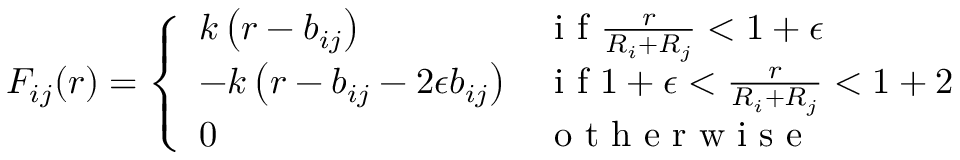<formula> <loc_0><loc_0><loc_500><loc_500>F _ { i j } ( r ) = \left \{ \begin{array} { l l } { k \left ( r - b _ { i j } \right ) } & { i f \frac { r } { R _ { i } + R _ { j } } < 1 + \epsilon } \\ { - k \left ( r - b _ { i j } - 2 \epsilon b _ { i j } \right ) } & { i f 1 + \epsilon < \frac { r } { R _ { i } + R _ { j } } < 1 + 2 } \\ { 0 } & { o t h e r w i s e } \end{array}</formula> 